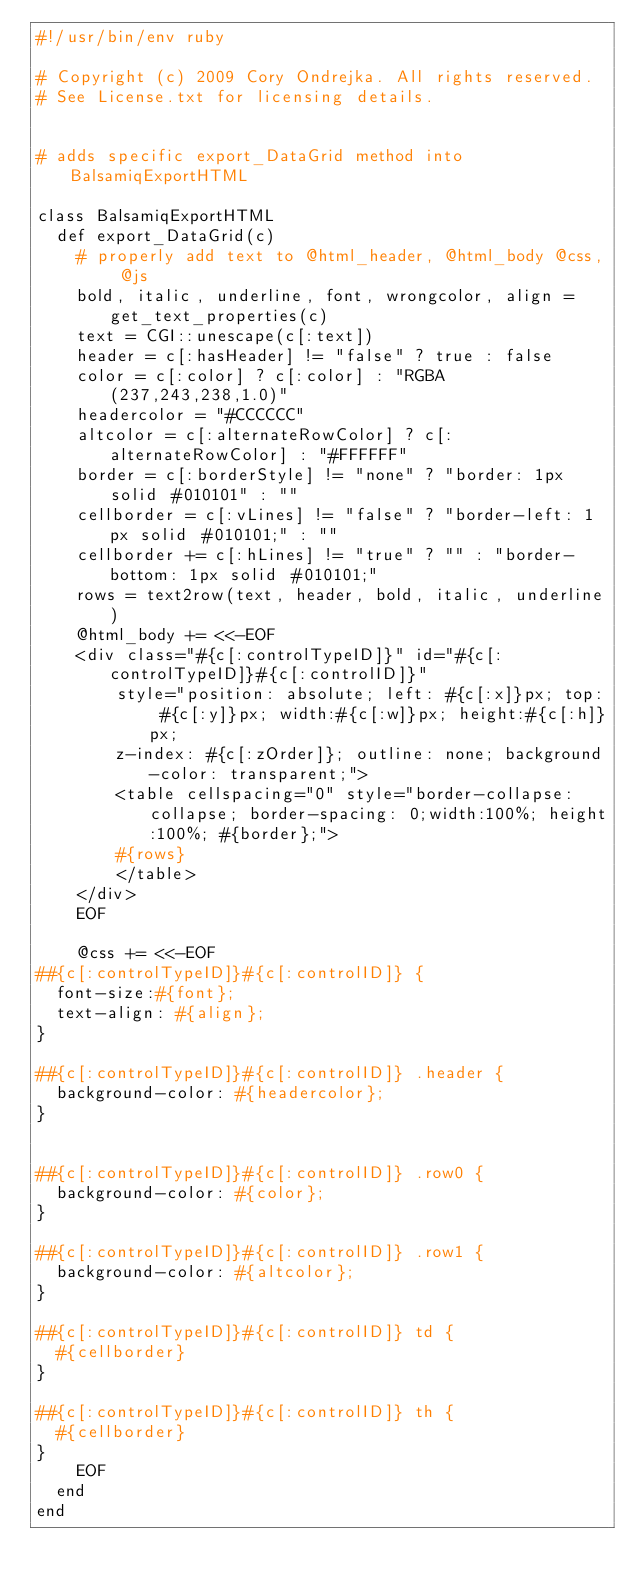<code> <loc_0><loc_0><loc_500><loc_500><_Ruby_>#!/usr/bin/env ruby
      
# Copyright (c) 2009 Cory Ondrejka. All rights reserved.
# See License.txt for licensing details.


# adds specific export_DataGrid method into BalsamiqExportHTML

class BalsamiqExportHTML
  def export_DataGrid(c)
    # properly add text to @html_header, @html_body @css, @js 
    bold, italic, underline, font, wrongcolor, align = get_text_properties(c)
    text = CGI::unescape(c[:text])
    header = c[:hasHeader] != "false" ? true : false
    color = c[:color] ? c[:color] : "RGBA(237,243,238,1.0)"
    headercolor = "#CCCCCC"
    altcolor = c[:alternateRowColor] ? c[:alternateRowColor] : "#FFFFFF"
    border = c[:borderStyle] != "none" ? "border: 1px solid #010101" : ""
    cellborder = c[:vLines] != "false" ? "border-left: 1px solid #010101;" : ""
    cellborder += c[:hLines] != "true" ? "" : "border-bottom: 1px solid #010101;"
    rows = text2row(text, header, bold, italic, underline)
    @html_body += <<-EOF
    <div class="#{c[:controlTypeID]}" id="#{c[:controlTypeID]}#{c[:controlID]}"
        style="position: absolute; left: #{c[:x]}px; top: #{c[:y]}px; width:#{c[:w]}px; height:#{c[:h]}px;
        z-index: #{c[:zOrder]}; outline: none; background-color: transparent;">
        <table cellspacing="0" style="border-collapse: collapse; border-spacing: 0;width:100%; height:100%; #{border};">
        #{rows}
        </table>
    </div>
    EOF
    
    @css += <<-EOF
##{c[:controlTypeID]}#{c[:controlID]} {
  font-size:#{font}; 
  text-align: #{align}; 
}

##{c[:controlTypeID]}#{c[:controlID]} .header {
  background-color: #{headercolor};
}


##{c[:controlTypeID]}#{c[:controlID]} .row0 {
  background-color: #{color};
}

##{c[:controlTypeID]}#{c[:controlID]} .row1 {
  background-color: #{altcolor};
}

##{c[:controlTypeID]}#{c[:controlID]} td {
  #{cellborder}
}

##{c[:controlTypeID]}#{c[:controlID]} th {
  #{cellborder}
}
    EOF
  end  
end
</code> 